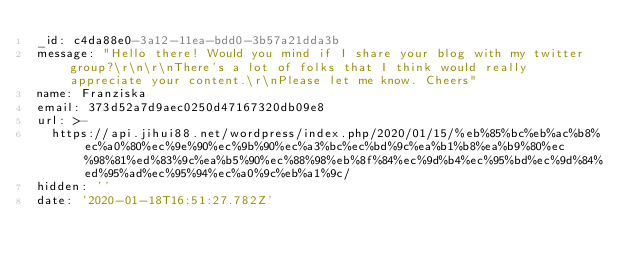Convert code to text. <code><loc_0><loc_0><loc_500><loc_500><_YAML_>_id: c4da88e0-3a12-11ea-bdd0-3b57a21dda3b
message: "Hello there! Would you mind if I share your blog with my twitter group?\r\n\r\nThere's a lot of folks that I think would really appreciate your content.\r\nPlease let me know. Cheers"
name: Franziska
email: 373d52a7d9aec0250d47167320db09e8
url: >-
  https://api.jihui88.net/wordpress/index.php/2020/01/15/%eb%85%bc%eb%ac%b8%ec%a0%80%ec%9e%90%ec%9b%90%ec%a3%bc%ec%bd%9c%ea%b1%b8%ea%b9%80%ec%98%81%ed%83%9c%ea%b5%90%ec%88%98%eb%8f%84%ec%9d%b4%ec%95%bd%ec%9d%84%ed%95%ad%ec%95%94%ec%a0%9c%eb%a1%9c/
hidden: ''
date: '2020-01-18T16:51:27.782Z'
</code> 